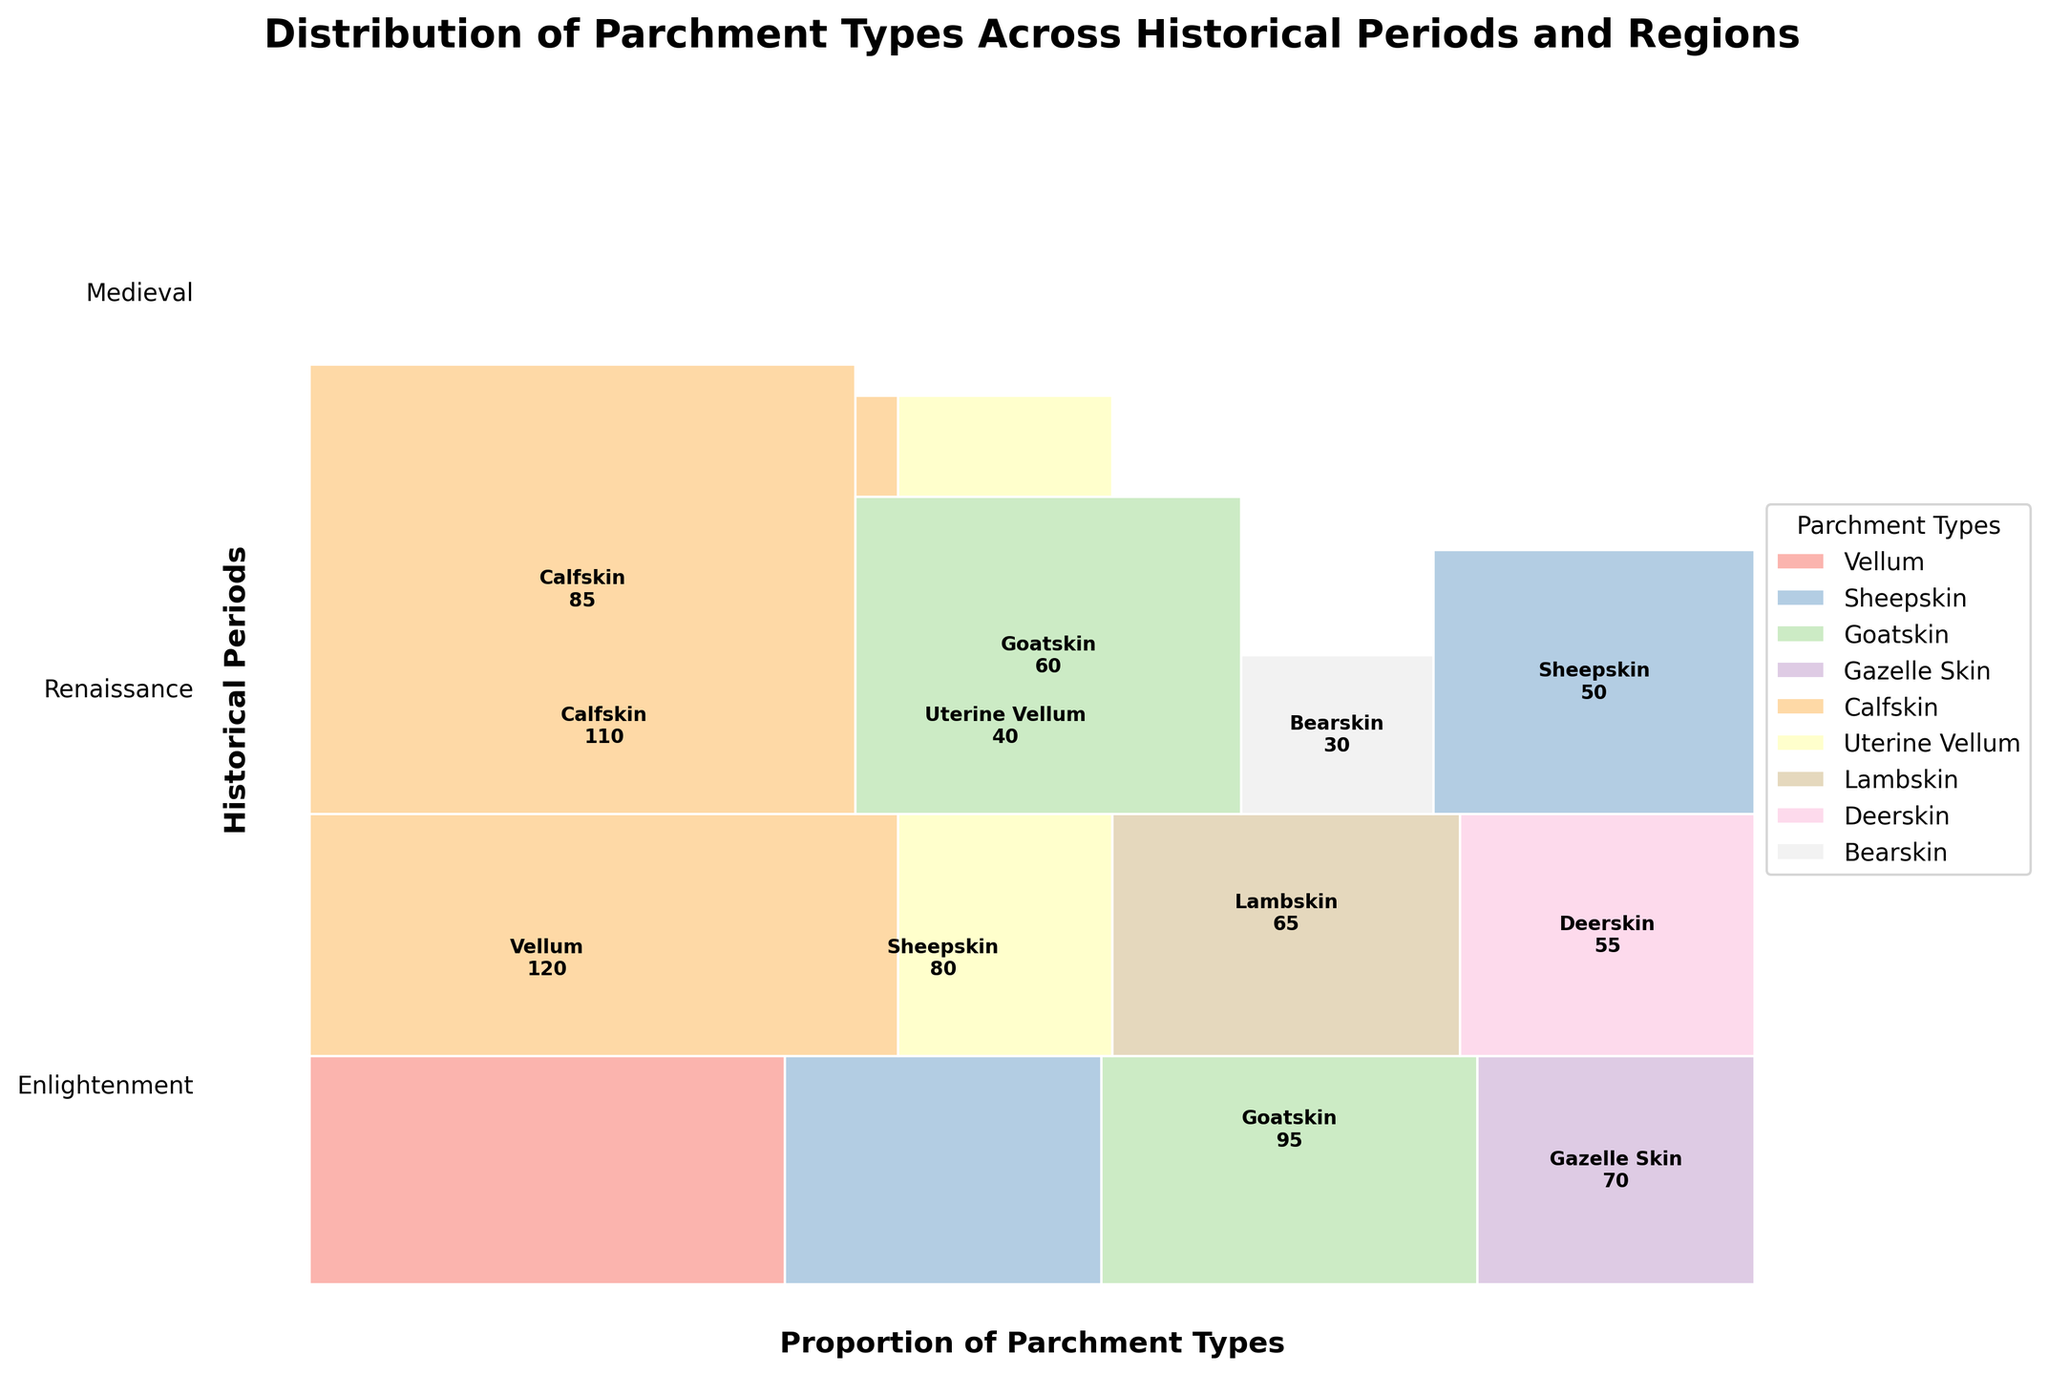What is the title of the mosaic plot? The title of the mosaic plot is provided at the top of the figure, intended to summarize the visual information.
Answer: Distribution of Parchment Types Across Historical Periods and Regions Which historical period has the dominance of Sheepskin? To find this, look for the sections labeled as "Sheepskin" and identify the corresponding historical period.
Answer: Medieval and Enlightenment How many types of parchment are used during the Renaissance period in Italy? Check the segments corresponding to the Renaissance period and Italy, count distinct types of parchment.
Answer: 2 Which region in the Enlightenment period used the least common parchment type and what was it? Identify the segment in the Enlightenment period with the smallest proportion and note its corresponding region and type.
Answer: Russia, Bearskin Compare the total counts of parchment types used in the Medieval period in Western Europe and Byzantine Empire. Which is greater? Sum the count of each type in the specified regions during the Medieval period and compare them.
Answer: Western Europe What is the total count of Calfskin parchment across all historical periods? Summing the counts of all segments labeled as "Calfskin" in the figure.
Answer: 195 During the Renaissance, which region did not employ Uterine Vellum in their parchments? Identify regions in the Renaissance period and check which ones do not have Uterine Vellum in their segments.
Answer: France, England How does the use of Goatskin in the Byzantine Empire during the Medieval period compare to its use in the Netherlands during the Enlightenment period? Compare the width of the segments labeled "Goatskin" in the specified periods and regions.
Answer: Greater in the Byzantine Empire How many historical periods are presented in the mosaic plot? Count the distinct labels or sections corresponding to historical periods in the y-axis direction.
Answer: 3 Which parchment type appears exclusively in the Enlightenment period? Scan the segments in the Enlightenment period and check if the parchment does not appear in other periods.
Answer: Bearskin 